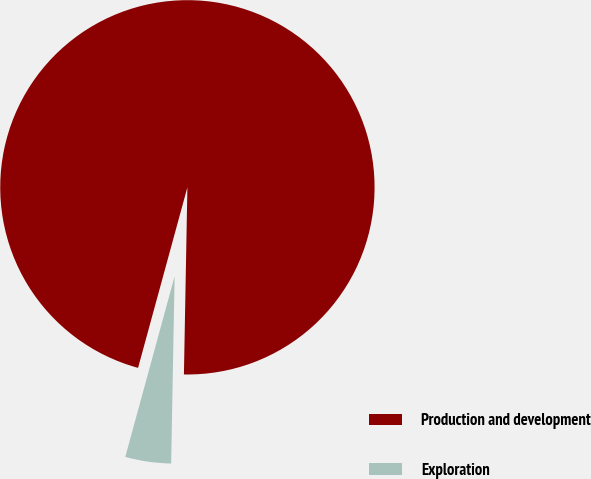Convert chart to OTSL. <chart><loc_0><loc_0><loc_500><loc_500><pie_chart><fcel>Production and development<fcel>Exploration<nl><fcel>96.05%<fcel>3.95%<nl></chart> 